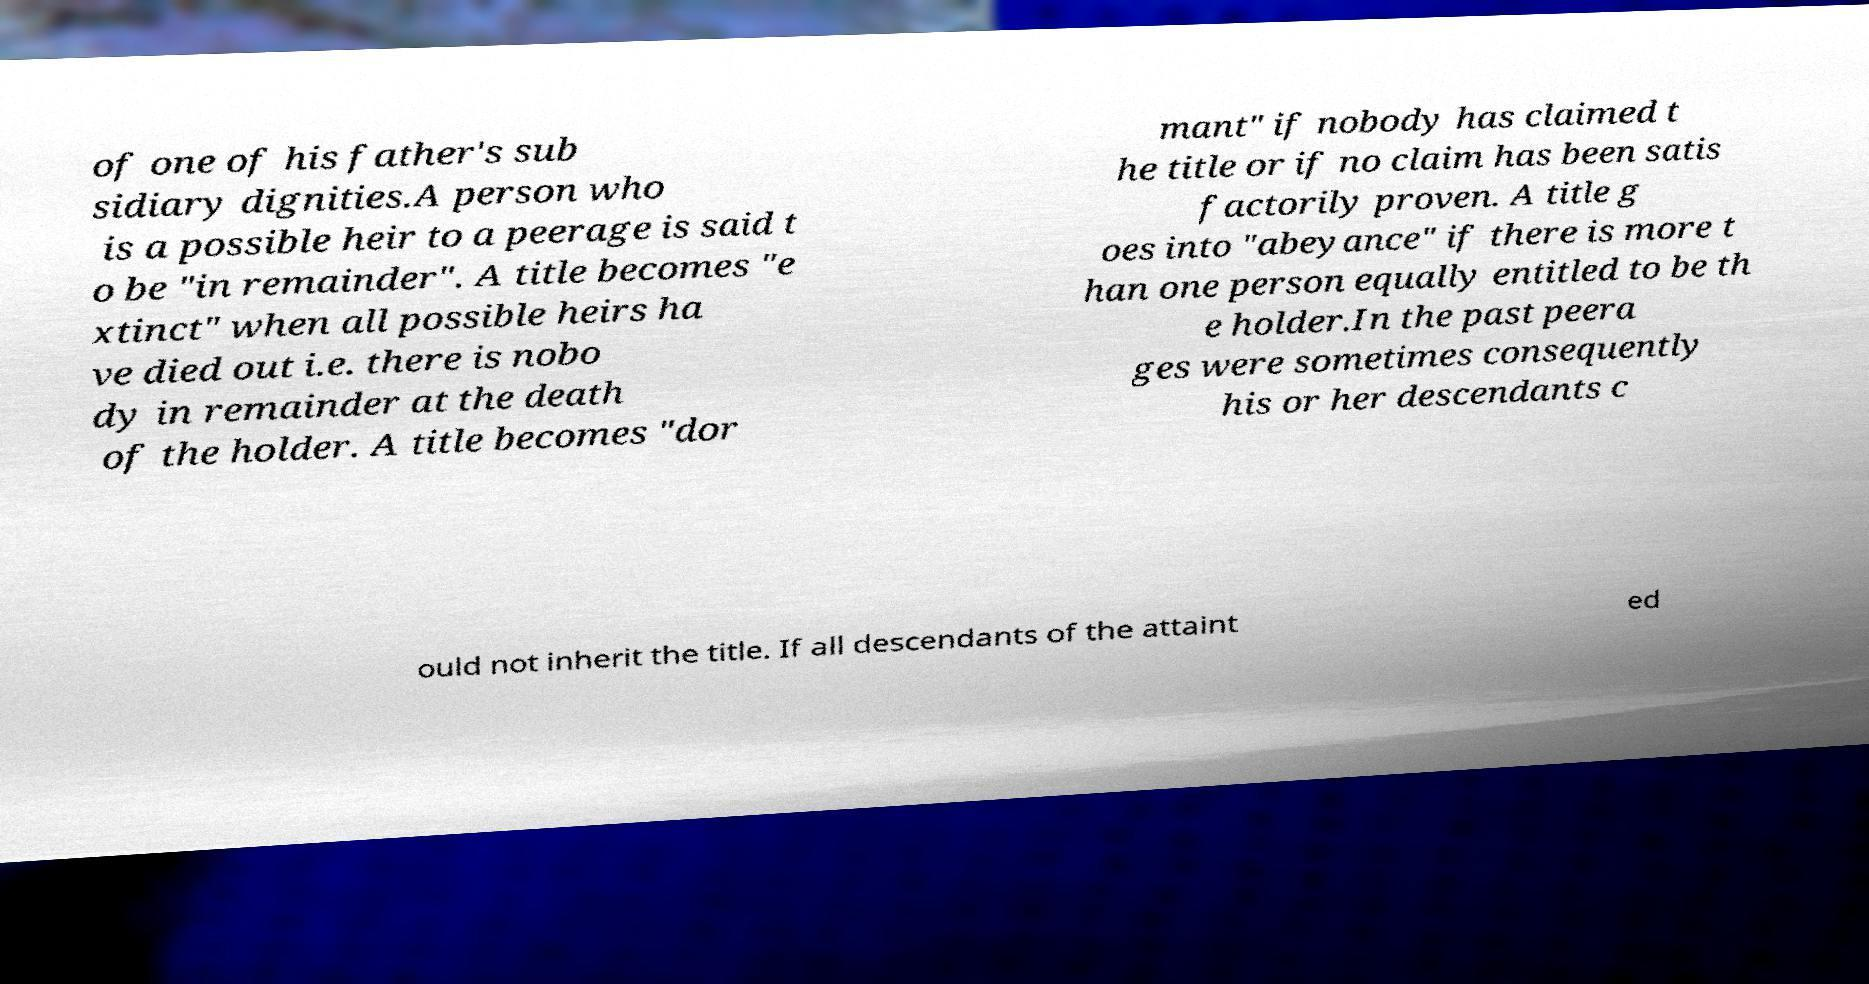Could you assist in decoding the text presented in this image and type it out clearly? of one of his father's sub sidiary dignities.A person who is a possible heir to a peerage is said t o be "in remainder". A title becomes "e xtinct" when all possible heirs ha ve died out i.e. there is nobo dy in remainder at the death of the holder. A title becomes "dor mant" if nobody has claimed t he title or if no claim has been satis factorily proven. A title g oes into "abeyance" if there is more t han one person equally entitled to be th e holder.In the past peera ges were sometimes consequently his or her descendants c ould not inherit the title. If all descendants of the attaint ed 